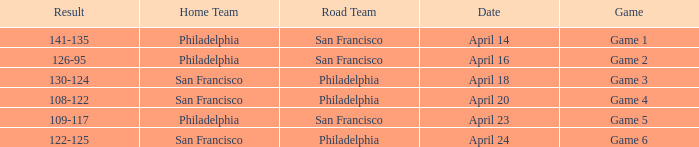Which games had Philadelphia as home team? Game 1, Game 2, Game 5. 